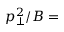<formula> <loc_0><loc_0><loc_500><loc_500>p _ { \bot } ^ { 2 } / B =</formula> 